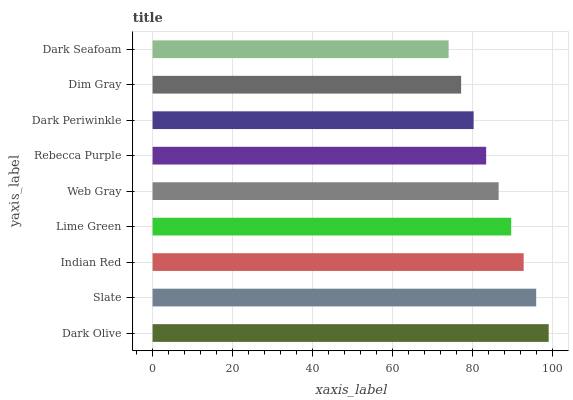Is Dark Seafoam the minimum?
Answer yes or no. Yes. Is Dark Olive the maximum?
Answer yes or no. Yes. Is Slate the minimum?
Answer yes or no. No. Is Slate the maximum?
Answer yes or no. No. Is Dark Olive greater than Slate?
Answer yes or no. Yes. Is Slate less than Dark Olive?
Answer yes or no. Yes. Is Slate greater than Dark Olive?
Answer yes or no. No. Is Dark Olive less than Slate?
Answer yes or no. No. Is Web Gray the high median?
Answer yes or no. Yes. Is Web Gray the low median?
Answer yes or no. Yes. Is Dark Olive the high median?
Answer yes or no. No. Is Slate the low median?
Answer yes or no. No. 